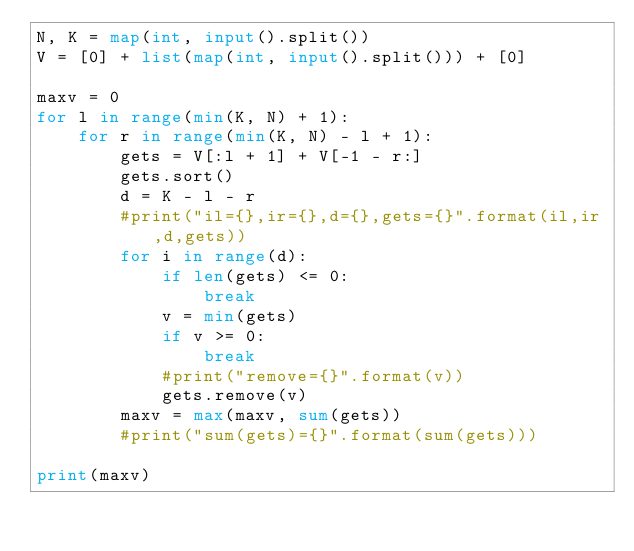<code> <loc_0><loc_0><loc_500><loc_500><_Python_>N, K = map(int, input().split())
V = [0] + list(map(int, input().split())) + [0]

maxv = 0
for l in range(min(K, N) + 1):
    for r in range(min(K, N) - l + 1):
        gets = V[:l + 1] + V[-1 - r:]
        gets.sort()
        d = K - l - r
        #print("il={},ir={},d={},gets={}".format(il,ir,d,gets))
        for i in range(d):
            if len(gets) <= 0:
                break
            v = min(gets)
            if v >= 0:
                break
            #print("remove={}".format(v))
            gets.remove(v)
        maxv = max(maxv, sum(gets))
        #print("sum(gets)={}".format(sum(gets)))

print(maxv)
</code> 